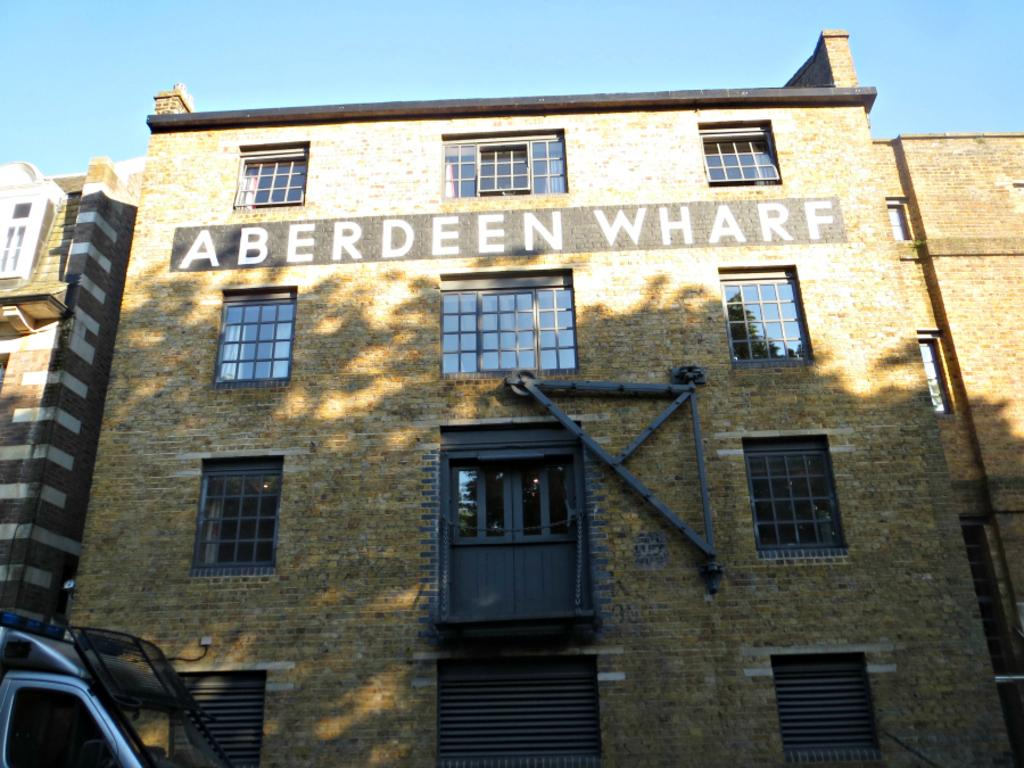What type of structure is present in the image? There is a building in the image. What feature of the building can be seen in the image? There are windows visible in the image. What part of the natural environment is visible in the image? The sky is visible in the image. What mode of transportation can be seen in the image? There is a motor vehicle in the image. Where is the twig located in the image? There is no twig present in the image. What type of food is being served in the lunchroom in the image? There is no lunchroom present in the image. 